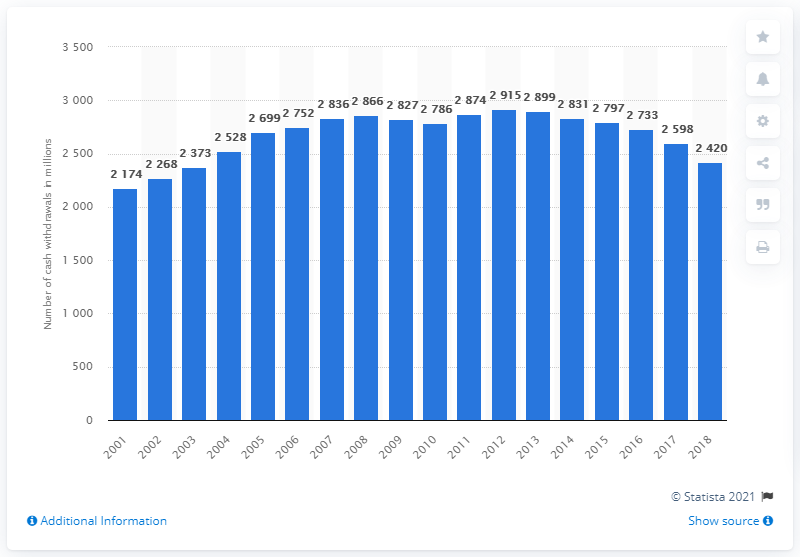Mention a couple of crucial points in this snapshot. There were 2,420 ATM withdrawal transactions in 2018. 